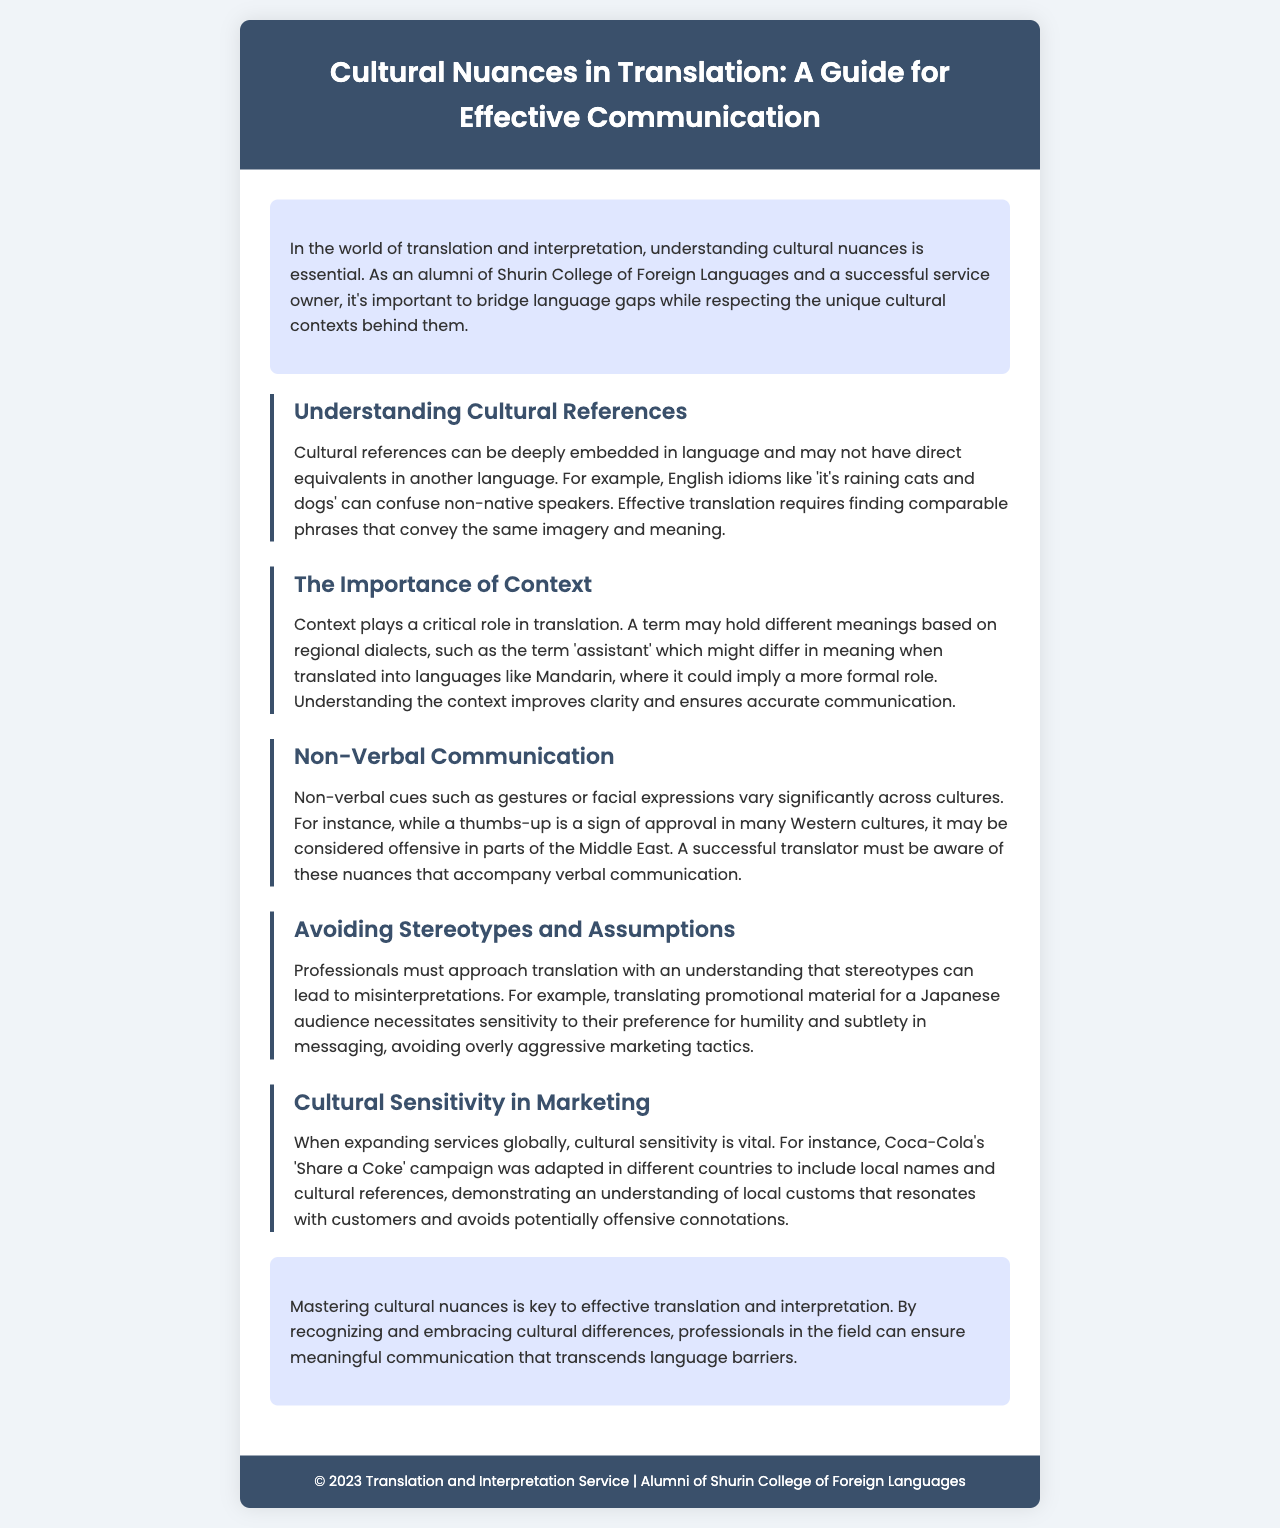What is the title of the brochure? The title of the brochure is presented prominently at the top of the document.
Answer: Cultural Nuances in Translation: A Guide for Effective Communication What color is the header background? The document mentions the header background color in the styling section.
Answer: #3a506b Which section discusses non-verbal cues? The topic of non-verbal cues is listed as one of the sections in the content area.
Answer: Non-Verbal Communication What is an example of a cultural reference mentioned? The document provides an idiom as a cultural reference example in the relevant section.
Answer: it's raining cats and dogs What does the translator need to understand regarding the term 'assistant'? The document emphasizes the importance of context for accurate translation of specific terms.
Answer: Different meanings What did Coca-Cola adapt in their 'Share a Coke' campaign? The document explains an example from marketing related to cultural sensitivity.
Answer: Local names and cultural references What is key to effective translation and interpretation? The conclusion summarizes the main focus of the document regarding translation practices.
Answer: Mastering cultural nuances Which alumni college is mentioned in the brochure? The introductory text specifies the college affiliation of the service owner.
Answer: Shurin College of Foreign Languages 